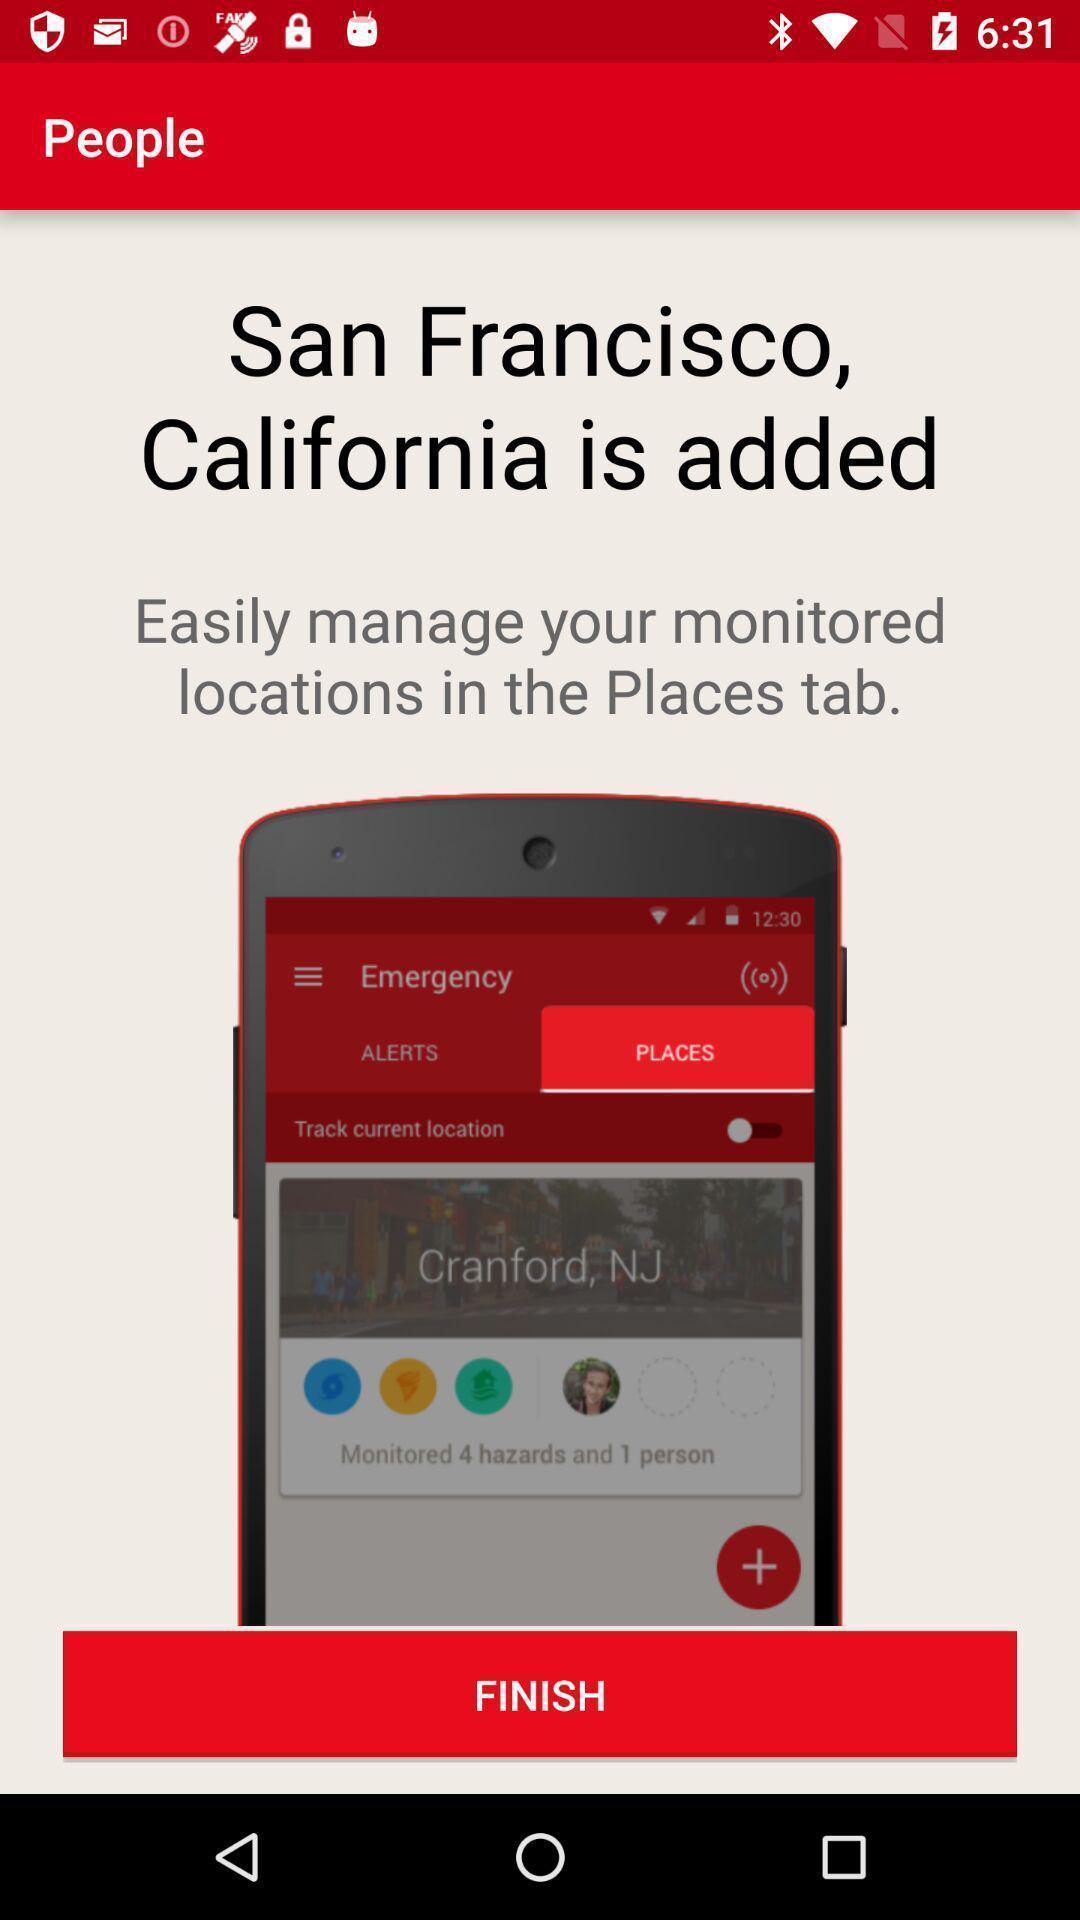Summarize the information in this screenshot. Page displaying information about application. 